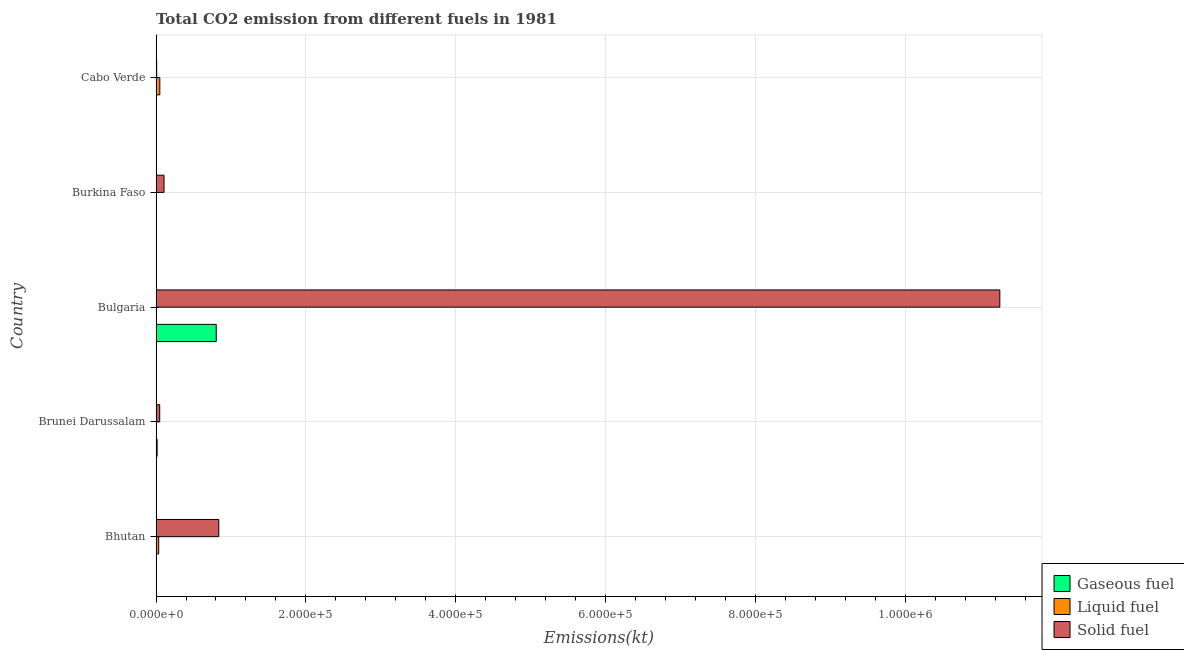How many different coloured bars are there?
Offer a terse response. 3. How many groups of bars are there?
Provide a succinct answer. 5. Are the number of bars per tick equal to the number of legend labels?
Your response must be concise. Yes. Are the number of bars on each tick of the Y-axis equal?
Offer a terse response. Yes. How many bars are there on the 2nd tick from the top?
Your answer should be compact. 3. What is the label of the 4th group of bars from the top?
Offer a terse response. Brunei Darussalam. In how many cases, is the number of bars for a given country not equal to the number of legend labels?
Keep it short and to the point. 0. What is the amount of co2 emissions from gaseous fuel in Brunei Darussalam?
Offer a very short reply. 1470.47. Across all countries, what is the maximum amount of co2 emissions from liquid fuel?
Your response must be concise. 5082.46. Across all countries, what is the minimum amount of co2 emissions from solid fuel?
Make the answer very short. 861.75. In which country was the amount of co2 emissions from gaseous fuel maximum?
Your answer should be very brief. Bulgaria. In which country was the amount of co2 emissions from liquid fuel minimum?
Your answer should be compact. Burkina Faso. What is the total amount of co2 emissions from solid fuel in the graph?
Provide a succinct answer. 1.23e+06. What is the difference between the amount of co2 emissions from solid fuel in Bhutan and that in Burkina Faso?
Your answer should be compact. 7.31e+04. What is the difference between the amount of co2 emissions from liquid fuel in Bulgaria and the amount of co2 emissions from gaseous fuel in Burkina Faso?
Give a very brief answer. -407.04. What is the average amount of co2 emissions from solid fuel per country?
Ensure brevity in your answer.  2.45e+05. What is the difference between the amount of co2 emissions from gaseous fuel and amount of co2 emissions from liquid fuel in Burkina Faso?
Your response must be concise. 524.38. In how many countries, is the amount of co2 emissions from gaseous fuel greater than 80000 kt?
Your answer should be compact. 1. Is the difference between the amount of co2 emissions from gaseous fuel in Burkina Faso and Cabo Verde greater than the difference between the amount of co2 emissions from solid fuel in Burkina Faso and Cabo Verde?
Ensure brevity in your answer.  No. What is the difference between the highest and the second highest amount of co2 emissions from solid fuel?
Keep it short and to the point. 1.04e+06. What is the difference between the highest and the lowest amount of co2 emissions from gaseous fuel?
Make the answer very short. 8.03e+04. In how many countries, is the amount of co2 emissions from solid fuel greater than the average amount of co2 emissions from solid fuel taken over all countries?
Offer a very short reply. 1. Is the sum of the amount of co2 emissions from liquid fuel in Bhutan and Cabo Verde greater than the maximum amount of co2 emissions from gaseous fuel across all countries?
Your answer should be compact. No. What does the 1st bar from the top in Bhutan represents?
Your answer should be compact. Solid fuel. What does the 1st bar from the bottom in Burkina Faso represents?
Provide a succinct answer. Gaseous fuel. Is it the case that in every country, the sum of the amount of co2 emissions from gaseous fuel and amount of co2 emissions from liquid fuel is greater than the amount of co2 emissions from solid fuel?
Offer a terse response. No. How many bars are there?
Your answer should be compact. 15. How many countries are there in the graph?
Give a very brief answer. 5. What is the difference between two consecutive major ticks on the X-axis?
Provide a short and direct response. 2.00e+05. Where does the legend appear in the graph?
Provide a short and direct response. Bottom right. What is the title of the graph?
Give a very brief answer. Total CO2 emission from different fuels in 1981. Does "Primary education" appear as one of the legend labels in the graph?
Ensure brevity in your answer.  No. What is the label or title of the X-axis?
Offer a terse response. Emissions(kt). What is the Emissions(kt) in Gaseous fuel in Bhutan?
Offer a very short reply. 25.67. What is the Emissions(kt) in Liquid fuel in Bhutan?
Provide a short and direct response. 3567.99. What is the Emissions(kt) in Solid fuel in Bhutan?
Your answer should be compact. 8.38e+04. What is the Emissions(kt) of Gaseous fuel in Brunei Darussalam?
Your response must be concise. 1470.47. What is the Emissions(kt) in Liquid fuel in Brunei Darussalam?
Offer a terse response. 557.38. What is the Emissions(kt) in Solid fuel in Brunei Darussalam?
Provide a short and direct response. 4935.78. What is the Emissions(kt) of Gaseous fuel in Bulgaria?
Your answer should be very brief. 8.03e+04. What is the Emissions(kt) in Liquid fuel in Bulgaria?
Your answer should be compact. 150.35. What is the Emissions(kt) of Solid fuel in Bulgaria?
Ensure brevity in your answer.  1.13e+06. What is the Emissions(kt) in Gaseous fuel in Burkina Faso?
Make the answer very short. 557.38. What is the Emissions(kt) in Liquid fuel in Burkina Faso?
Your response must be concise. 33. What is the Emissions(kt) in Solid fuel in Burkina Faso?
Make the answer very short. 1.07e+04. What is the Emissions(kt) in Gaseous fuel in Cabo Verde?
Offer a terse response. 33. What is the Emissions(kt) of Liquid fuel in Cabo Verde?
Make the answer very short. 5082.46. What is the Emissions(kt) in Solid fuel in Cabo Verde?
Make the answer very short. 861.75. Across all countries, what is the maximum Emissions(kt) in Gaseous fuel?
Offer a terse response. 8.03e+04. Across all countries, what is the maximum Emissions(kt) in Liquid fuel?
Keep it short and to the point. 5082.46. Across all countries, what is the maximum Emissions(kt) of Solid fuel?
Give a very brief answer. 1.13e+06. Across all countries, what is the minimum Emissions(kt) of Gaseous fuel?
Provide a short and direct response. 25.67. Across all countries, what is the minimum Emissions(kt) of Liquid fuel?
Your answer should be compact. 33. Across all countries, what is the minimum Emissions(kt) of Solid fuel?
Keep it short and to the point. 861.75. What is the total Emissions(kt) of Gaseous fuel in the graph?
Offer a terse response. 8.24e+04. What is the total Emissions(kt) of Liquid fuel in the graph?
Your answer should be very brief. 9391.19. What is the total Emissions(kt) of Solid fuel in the graph?
Make the answer very short. 1.23e+06. What is the difference between the Emissions(kt) of Gaseous fuel in Bhutan and that in Brunei Darussalam?
Ensure brevity in your answer.  -1444.8. What is the difference between the Emissions(kt) in Liquid fuel in Bhutan and that in Brunei Darussalam?
Your response must be concise. 3010.61. What is the difference between the Emissions(kt) of Solid fuel in Bhutan and that in Brunei Darussalam?
Your answer should be very brief. 7.88e+04. What is the difference between the Emissions(kt) in Gaseous fuel in Bhutan and that in Bulgaria?
Your answer should be compact. -8.03e+04. What is the difference between the Emissions(kt) in Liquid fuel in Bhutan and that in Bulgaria?
Offer a terse response. 3417.64. What is the difference between the Emissions(kt) of Solid fuel in Bhutan and that in Bulgaria?
Your response must be concise. -1.04e+06. What is the difference between the Emissions(kt) of Gaseous fuel in Bhutan and that in Burkina Faso?
Provide a succinct answer. -531.72. What is the difference between the Emissions(kt) of Liquid fuel in Bhutan and that in Burkina Faso?
Ensure brevity in your answer.  3534.99. What is the difference between the Emissions(kt) in Solid fuel in Bhutan and that in Burkina Faso?
Your answer should be compact. 7.31e+04. What is the difference between the Emissions(kt) in Gaseous fuel in Bhutan and that in Cabo Verde?
Offer a very short reply. -7.33. What is the difference between the Emissions(kt) in Liquid fuel in Bhutan and that in Cabo Verde?
Offer a very short reply. -1514.47. What is the difference between the Emissions(kt) in Solid fuel in Bhutan and that in Cabo Verde?
Your answer should be compact. 8.29e+04. What is the difference between the Emissions(kt) of Gaseous fuel in Brunei Darussalam and that in Bulgaria?
Provide a short and direct response. -7.89e+04. What is the difference between the Emissions(kt) of Liquid fuel in Brunei Darussalam and that in Bulgaria?
Offer a terse response. 407.04. What is the difference between the Emissions(kt) in Solid fuel in Brunei Darussalam and that in Bulgaria?
Provide a succinct answer. -1.12e+06. What is the difference between the Emissions(kt) of Gaseous fuel in Brunei Darussalam and that in Burkina Faso?
Your response must be concise. 913.08. What is the difference between the Emissions(kt) of Liquid fuel in Brunei Darussalam and that in Burkina Faso?
Ensure brevity in your answer.  524.38. What is the difference between the Emissions(kt) of Solid fuel in Brunei Darussalam and that in Burkina Faso?
Your response must be concise. -5735.19. What is the difference between the Emissions(kt) of Gaseous fuel in Brunei Darussalam and that in Cabo Verde?
Keep it short and to the point. 1437.46. What is the difference between the Emissions(kt) of Liquid fuel in Brunei Darussalam and that in Cabo Verde?
Keep it short and to the point. -4525.08. What is the difference between the Emissions(kt) in Solid fuel in Brunei Darussalam and that in Cabo Verde?
Ensure brevity in your answer.  4074.04. What is the difference between the Emissions(kt) of Gaseous fuel in Bulgaria and that in Burkina Faso?
Your answer should be very brief. 7.98e+04. What is the difference between the Emissions(kt) in Liquid fuel in Bulgaria and that in Burkina Faso?
Provide a short and direct response. 117.34. What is the difference between the Emissions(kt) in Solid fuel in Bulgaria and that in Burkina Faso?
Ensure brevity in your answer.  1.12e+06. What is the difference between the Emissions(kt) in Gaseous fuel in Bulgaria and that in Cabo Verde?
Ensure brevity in your answer.  8.03e+04. What is the difference between the Emissions(kt) in Liquid fuel in Bulgaria and that in Cabo Verde?
Your response must be concise. -4932.11. What is the difference between the Emissions(kt) in Solid fuel in Bulgaria and that in Cabo Verde?
Make the answer very short. 1.13e+06. What is the difference between the Emissions(kt) in Gaseous fuel in Burkina Faso and that in Cabo Verde?
Offer a very short reply. 524.38. What is the difference between the Emissions(kt) in Liquid fuel in Burkina Faso and that in Cabo Verde?
Keep it short and to the point. -5049.46. What is the difference between the Emissions(kt) in Solid fuel in Burkina Faso and that in Cabo Verde?
Your answer should be compact. 9809.23. What is the difference between the Emissions(kt) in Gaseous fuel in Bhutan and the Emissions(kt) in Liquid fuel in Brunei Darussalam?
Your answer should be very brief. -531.72. What is the difference between the Emissions(kt) in Gaseous fuel in Bhutan and the Emissions(kt) in Solid fuel in Brunei Darussalam?
Keep it short and to the point. -4910.11. What is the difference between the Emissions(kt) of Liquid fuel in Bhutan and the Emissions(kt) of Solid fuel in Brunei Darussalam?
Your answer should be compact. -1367.79. What is the difference between the Emissions(kt) in Gaseous fuel in Bhutan and the Emissions(kt) in Liquid fuel in Bulgaria?
Give a very brief answer. -124.68. What is the difference between the Emissions(kt) of Gaseous fuel in Bhutan and the Emissions(kt) of Solid fuel in Bulgaria?
Your answer should be compact. -1.13e+06. What is the difference between the Emissions(kt) in Liquid fuel in Bhutan and the Emissions(kt) in Solid fuel in Bulgaria?
Offer a very short reply. -1.12e+06. What is the difference between the Emissions(kt) in Gaseous fuel in Bhutan and the Emissions(kt) in Liquid fuel in Burkina Faso?
Give a very brief answer. -7.33. What is the difference between the Emissions(kt) of Gaseous fuel in Bhutan and the Emissions(kt) of Solid fuel in Burkina Faso?
Ensure brevity in your answer.  -1.06e+04. What is the difference between the Emissions(kt) in Liquid fuel in Bhutan and the Emissions(kt) in Solid fuel in Burkina Faso?
Keep it short and to the point. -7102.98. What is the difference between the Emissions(kt) in Gaseous fuel in Bhutan and the Emissions(kt) in Liquid fuel in Cabo Verde?
Give a very brief answer. -5056.79. What is the difference between the Emissions(kt) of Gaseous fuel in Bhutan and the Emissions(kt) of Solid fuel in Cabo Verde?
Offer a terse response. -836.08. What is the difference between the Emissions(kt) in Liquid fuel in Bhutan and the Emissions(kt) in Solid fuel in Cabo Verde?
Ensure brevity in your answer.  2706.25. What is the difference between the Emissions(kt) in Gaseous fuel in Brunei Darussalam and the Emissions(kt) in Liquid fuel in Bulgaria?
Give a very brief answer. 1320.12. What is the difference between the Emissions(kt) in Gaseous fuel in Brunei Darussalam and the Emissions(kt) in Solid fuel in Bulgaria?
Offer a terse response. -1.12e+06. What is the difference between the Emissions(kt) of Liquid fuel in Brunei Darussalam and the Emissions(kt) of Solid fuel in Bulgaria?
Ensure brevity in your answer.  -1.13e+06. What is the difference between the Emissions(kt) of Gaseous fuel in Brunei Darussalam and the Emissions(kt) of Liquid fuel in Burkina Faso?
Give a very brief answer. 1437.46. What is the difference between the Emissions(kt) of Gaseous fuel in Brunei Darussalam and the Emissions(kt) of Solid fuel in Burkina Faso?
Your answer should be compact. -9200.5. What is the difference between the Emissions(kt) in Liquid fuel in Brunei Darussalam and the Emissions(kt) in Solid fuel in Burkina Faso?
Offer a terse response. -1.01e+04. What is the difference between the Emissions(kt) of Gaseous fuel in Brunei Darussalam and the Emissions(kt) of Liquid fuel in Cabo Verde?
Give a very brief answer. -3611.99. What is the difference between the Emissions(kt) of Gaseous fuel in Brunei Darussalam and the Emissions(kt) of Solid fuel in Cabo Verde?
Ensure brevity in your answer.  608.72. What is the difference between the Emissions(kt) of Liquid fuel in Brunei Darussalam and the Emissions(kt) of Solid fuel in Cabo Verde?
Provide a succinct answer. -304.36. What is the difference between the Emissions(kt) of Gaseous fuel in Bulgaria and the Emissions(kt) of Liquid fuel in Burkina Faso?
Offer a terse response. 8.03e+04. What is the difference between the Emissions(kt) of Gaseous fuel in Bulgaria and the Emissions(kt) of Solid fuel in Burkina Faso?
Provide a succinct answer. 6.97e+04. What is the difference between the Emissions(kt) of Liquid fuel in Bulgaria and the Emissions(kt) of Solid fuel in Burkina Faso?
Your answer should be compact. -1.05e+04. What is the difference between the Emissions(kt) in Gaseous fuel in Bulgaria and the Emissions(kt) in Liquid fuel in Cabo Verde?
Ensure brevity in your answer.  7.53e+04. What is the difference between the Emissions(kt) in Gaseous fuel in Bulgaria and the Emissions(kt) in Solid fuel in Cabo Verde?
Provide a short and direct response. 7.95e+04. What is the difference between the Emissions(kt) in Liquid fuel in Bulgaria and the Emissions(kt) in Solid fuel in Cabo Verde?
Offer a very short reply. -711.4. What is the difference between the Emissions(kt) in Gaseous fuel in Burkina Faso and the Emissions(kt) in Liquid fuel in Cabo Verde?
Give a very brief answer. -4525.08. What is the difference between the Emissions(kt) in Gaseous fuel in Burkina Faso and the Emissions(kt) in Solid fuel in Cabo Verde?
Your answer should be very brief. -304.36. What is the difference between the Emissions(kt) of Liquid fuel in Burkina Faso and the Emissions(kt) of Solid fuel in Cabo Verde?
Offer a very short reply. -828.74. What is the average Emissions(kt) of Gaseous fuel per country?
Provide a succinct answer. 1.65e+04. What is the average Emissions(kt) of Liquid fuel per country?
Make the answer very short. 1878.24. What is the average Emissions(kt) of Solid fuel per country?
Your response must be concise. 2.45e+05. What is the difference between the Emissions(kt) in Gaseous fuel and Emissions(kt) in Liquid fuel in Bhutan?
Make the answer very short. -3542.32. What is the difference between the Emissions(kt) in Gaseous fuel and Emissions(kt) in Solid fuel in Bhutan?
Your answer should be very brief. -8.37e+04. What is the difference between the Emissions(kt) in Liquid fuel and Emissions(kt) in Solid fuel in Bhutan?
Offer a very short reply. -8.02e+04. What is the difference between the Emissions(kt) in Gaseous fuel and Emissions(kt) in Liquid fuel in Brunei Darussalam?
Your response must be concise. 913.08. What is the difference between the Emissions(kt) in Gaseous fuel and Emissions(kt) in Solid fuel in Brunei Darussalam?
Provide a short and direct response. -3465.32. What is the difference between the Emissions(kt) in Liquid fuel and Emissions(kt) in Solid fuel in Brunei Darussalam?
Provide a succinct answer. -4378.4. What is the difference between the Emissions(kt) of Gaseous fuel and Emissions(kt) of Liquid fuel in Bulgaria?
Offer a very short reply. 8.02e+04. What is the difference between the Emissions(kt) of Gaseous fuel and Emissions(kt) of Solid fuel in Bulgaria?
Provide a short and direct response. -1.05e+06. What is the difference between the Emissions(kt) in Liquid fuel and Emissions(kt) in Solid fuel in Bulgaria?
Provide a succinct answer. -1.13e+06. What is the difference between the Emissions(kt) of Gaseous fuel and Emissions(kt) of Liquid fuel in Burkina Faso?
Keep it short and to the point. 524.38. What is the difference between the Emissions(kt) in Gaseous fuel and Emissions(kt) in Solid fuel in Burkina Faso?
Offer a very short reply. -1.01e+04. What is the difference between the Emissions(kt) of Liquid fuel and Emissions(kt) of Solid fuel in Burkina Faso?
Ensure brevity in your answer.  -1.06e+04. What is the difference between the Emissions(kt) of Gaseous fuel and Emissions(kt) of Liquid fuel in Cabo Verde?
Your response must be concise. -5049.46. What is the difference between the Emissions(kt) in Gaseous fuel and Emissions(kt) in Solid fuel in Cabo Verde?
Offer a very short reply. -828.74. What is the difference between the Emissions(kt) of Liquid fuel and Emissions(kt) of Solid fuel in Cabo Verde?
Offer a very short reply. 4220.72. What is the ratio of the Emissions(kt) in Gaseous fuel in Bhutan to that in Brunei Darussalam?
Give a very brief answer. 0.02. What is the ratio of the Emissions(kt) in Liquid fuel in Bhutan to that in Brunei Darussalam?
Offer a terse response. 6.4. What is the ratio of the Emissions(kt) in Solid fuel in Bhutan to that in Brunei Darussalam?
Your answer should be compact. 16.97. What is the ratio of the Emissions(kt) of Gaseous fuel in Bhutan to that in Bulgaria?
Offer a terse response. 0. What is the ratio of the Emissions(kt) in Liquid fuel in Bhutan to that in Bulgaria?
Give a very brief answer. 23.73. What is the ratio of the Emissions(kt) of Solid fuel in Bhutan to that in Bulgaria?
Ensure brevity in your answer.  0.07. What is the ratio of the Emissions(kt) in Gaseous fuel in Bhutan to that in Burkina Faso?
Your answer should be very brief. 0.05. What is the ratio of the Emissions(kt) of Liquid fuel in Bhutan to that in Burkina Faso?
Keep it short and to the point. 108.11. What is the ratio of the Emissions(kt) in Solid fuel in Bhutan to that in Burkina Faso?
Your answer should be compact. 7.85. What is the ratio of the Emissions(kt) in Gaseous fuel in Bhutan to that in Cabo Verde?
Ensure brevity in your answer.  0.78. What is the ratio of the Emissions(kt) in Liquid fuel in Bhutan to that in Cabo Verde?
Provide a succinct answer. 0.7. What is the ratio of the Emissions(kt) in Solid fuel in Bhutan to that in Cabo Verde?
Provide a short and direct response. 97.2. What is the ratio of the Emissions(kt) in Gaseous fuel in Brunei Darussalam to that in Bulgaria?
Your answer should be compact. 0.02. What is the ratio of the Emissions(kt) of Liquid fuel in Brunei Darussalam to that in Bulgaria?
Offer a very short reply. 3.71. What is the ratio of the Emissions(kt) of Solid fuel in Brunei Darussalam to that in Bulgaria?
Provide a short and direct response. 0. What is the ratio of the Emissions(kt) of Gaseous fuel in Brunei Darussalam to that in Burkina Faso?
Provide a short and direct response. 2.64. What is the ratio of the Emissions(kt) in Liquid fuel in Brunei Darussalam to that in Burkina Faso?
Offer a very short reply. 16.89. What is the ratio of the Emissions(kt) in Solid fuel in Brunei Darussalam to that in Burkina Faso?
Offer a very short reply. 0.46. What is the ratio of the Emissions(kt) in Gaseous fuel in Brunei Darussalam to that in Cabo Verde?
Offer a terse response. 44.56. What is the ratio of the Emissions(kt) in Liquid fuel in Brunei Darussalam to that in Cabo Verde?
Make the answer very short. 0.11. What is the ratio of the Emissions(kt) of Solid fuel in Brunei Darussalam to that in Cabo Verde?
Give a very brief answer. 5.73. What is the ratio of the Emissions(kt) in Gaseous fuel in Bulgaria to that in Burkina Faso?
Offer a terse response. 144.14. What is the ratio of the Emissions(kt) in Liquid fuel in Bulgaria to that in Burkina Faso?
Offer a very short reply. 4.56. What is the ratio of the Emissions(kt) in Solid fuel in Bulgaria to that in Burkina Faso?
Keep it short and to the point. 105.51. What is the ratio of the Emissions(kt) of Gaseous fuel in Bulgaria to that in Cabo Verde?
Your answer should be compact. 2434.44. What is the ratio of the Emissions(kt) in Liquid fuel in Bulgaria to that in Cabo Verde?
Offer a terse response. 0.03. What is the ratio of the Emissions(kt) in Solid fuel in Bulgaria to that in Cabo Verde?
Keep it short and to the point. 1306.56. What is the ratio of the Emissions(kt) of Gaseous fuel in Burkina Faso to that in Cabo Verde?
Give a very brief answer. 16.89. What is the ratio of the Emissions(kt) in Liquid fuel in Burkina Faso to that in Cabo Verde?
Provide a short and direct response. 0.01. What is the ratio of the Emissions(kt) of Solid fuel in Burkina Faso to that in Cabo Verde?
Ensure brevity in your answer.  12.38. What is the difference between the highest and the second highest Emissions(kt) of Gaseous fuel?
Keep it short and to the point. 7.89e+04. What is the difference between the highest and the second highest Emissions(kt) of Liquid fuel?
Make the answer very short. 1514.47. What is the difference between the highest and the second highest Emissions(kt) in Solid fuel?
Offer a very short reply. 1.04e+06. What is the difference between the highest and the lowest Emissions(kt) in Gaseous fuel?
Keep it short and to the point. 8.03e+04. What is the difference between the highest and the lowest Emissions(kt) in Liquid fuel?
Ensure brevity in your answer.  5049.46. What is the difference between the highest and the lowest Emissions(kt) in Solid fuel?
Ensure brevity in your answer.  1.13e+06. 